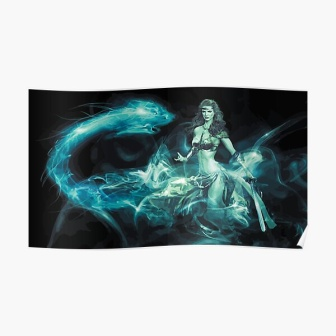Describe a brief, realistic scenario happening in the image. Seraphina stands vigilant at the edge of an ancient battlefield, her sword in hand. The blue smoke around her whispers the memories of past warriors, reminding her of the sacrifices made to defend the realm. As dawn approaches, the first light of day breaks through the darkness, symbolizing hope and a new beginning for the future. 